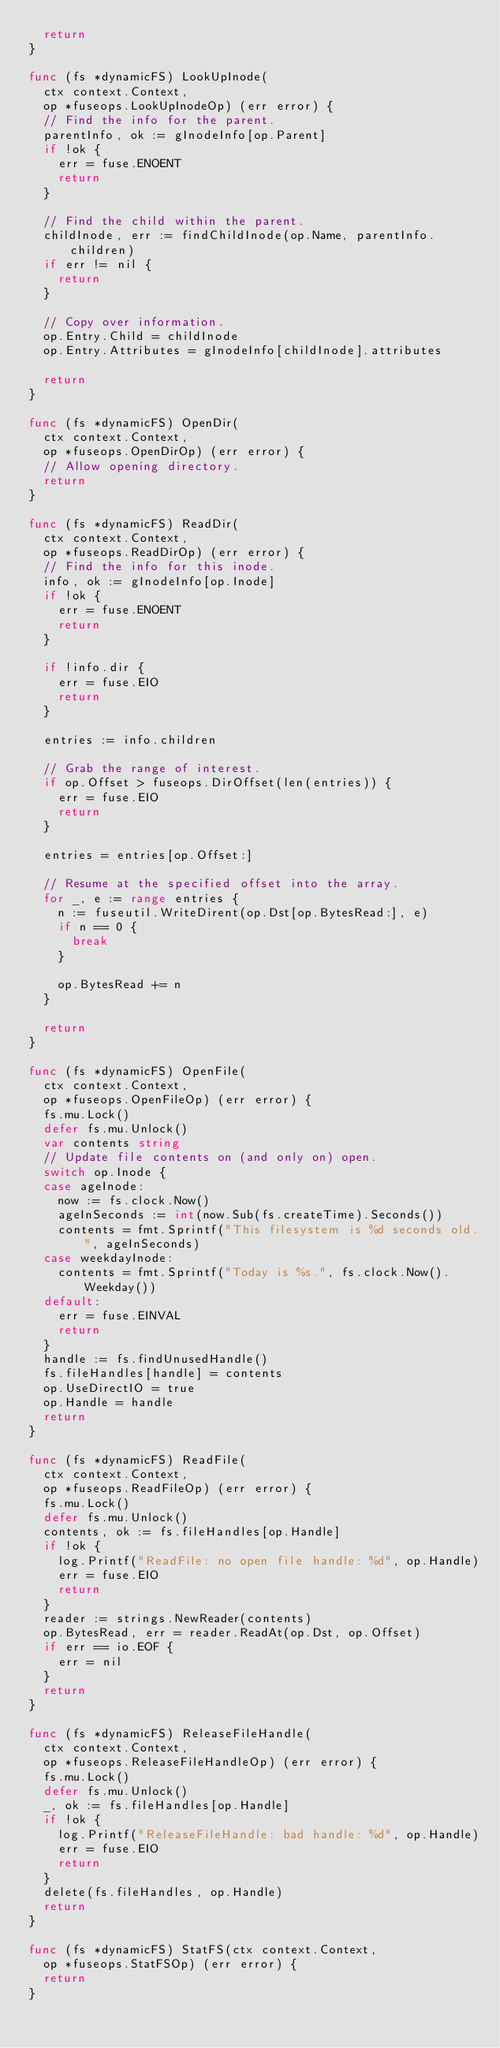<code> <loc_0><loc_0><loc_500><loc_500><_Go_>	return
}

func (fs *dynamicFS) LookUpInode(
	ctx context.Context,
	op *fuseops.LookUpInodeOp) (err error) {
	// Find the info for the parent.
	parentInfo, ok := gInodeInfo[op.Parent]
	if !ok {
		err = fuse.ENOENT
		return
	}

	// Find the child within the parent.
	childInode, err := findChildInode(op.Name, parentInfo.children)
	if err != nil {
		return
	}

	// Copy over information.
	op.Entry.Child = childInode
	op.Entry.Attributes = gInodeInfo[childInode].attributes

	return
}

func (fs *dynamicFS) OpenDir(
	ctx context.Context,
	op *fuseops.OpenDirOp) (err error) {
	// Allow opening directory.
	return
}

func (fs *dynamicFS) ReadDir(
	ctx context.Context,
	op *fuseops.ReadDirOp) (err error) {
	// Find the info for this inode.
	info, ok := gInodeInfo[op.Inode]
	if !ok {
		err = fuse.ENOENT
		return
	}

	if !info.dir {
		err = fuse.EIO
		return
	}

	entries := info.children

	// Grab the range of interest.
	if op.Offset > fuseops.DirOffset(len(entries)) {
		err = fuse.EIO
		return
	}

	entries = entries[op.Offset:]

	// Resume at the specified offset into the array.
	for _, e := range entries {
		n := fuseutil.WriteDirent(op.Dst[op.BytesRead:], e)
		if n == 0 {
			break
		}

		op.BytesRead += n
	}

	return
}

func (fs *dynamicFS) OpenFile(
	ctx context.Context,
	op *fuseops.OpenFileOp) (err error) {
	fs.mu.Lock()
	defer fs.mu.Unlock()
	var contents string
	// Update file contents on (and only on) open.
	switch op.Inode {
	case ageInode:
		now := fs.clock.Now()
		ageInSeconds := int(now.Sub(fs.createTime).Seconds())
		contents = fmt.Sprintf("This filesystem is %d seconds old.", ageInSeconds)
	case weekdayInode:
		contents = fmt.Sprintf("Today is %s.", fs.clock.Now().Weekday())
	default:
		err = fuse.EINVAL
		return
	}
	handle := fs.findUnusedHandle()
	fs.fileHandles[handle] = contents
	op.UseDirectIO = true
	op.Handle = handle
	return
}

func (fs *dynamicFS) ReadFile(
	ctx context.Context,
	op *fuseops.ReadFileOp) (err error) {
	fs.mu.Lock()
	defer fs.mu.Unlock()
	contents, ok := fs.fileHandles[op.Handle]
	if !ok {
		log.Printf("ReadFile: no open file handle: %d", op.Handle)
		err = fuse.EIO
		return
	}
	reader := strings.NewReader(contents)
	op.BytesRead, err = reader.ReadAt(op.Dst, op.Offset)
	if err == io.EOF {
		err = nil
	}
	return
}

func (fs *dynamicFS) ReleaseFileHandle(
	ctx context.Context,
	op *fuseops.ReleaseFileHandleOp) (err error) {
	fs.mu.Lock()
	defer fs.mu.Unlock()
	_, ok := fs.fileHandles[op.Handle]
	if !ok {
		log.Printf("ReleaseFileHandle: bad handle: %d", op.Handle)
		err = fuse.EIO
		return
	}
	delete(fs.fileHandles, op.Handle)
	return
}

func (fs *dynamicFS) StatFS(ctx context.Context,
	op *fuseops.StatFSOp) (err error) {
	return
}
</code> 